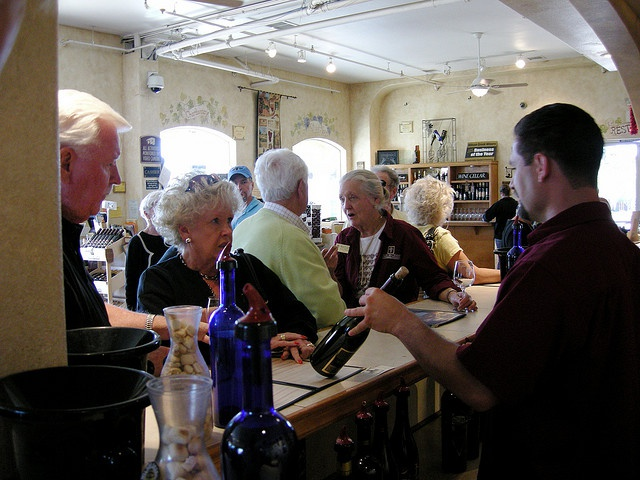Describe the objects in this image and their specific colors. I can see people in black, maroon, gray, and darkgray tones, people in black, maroon, gray, and darkgray tones, people in black, maroon, gray, and darkgray tones, people in black, maroon, tan, and brown tones, and people in black, gray, darkgray, and darkgreen tones in this image. 